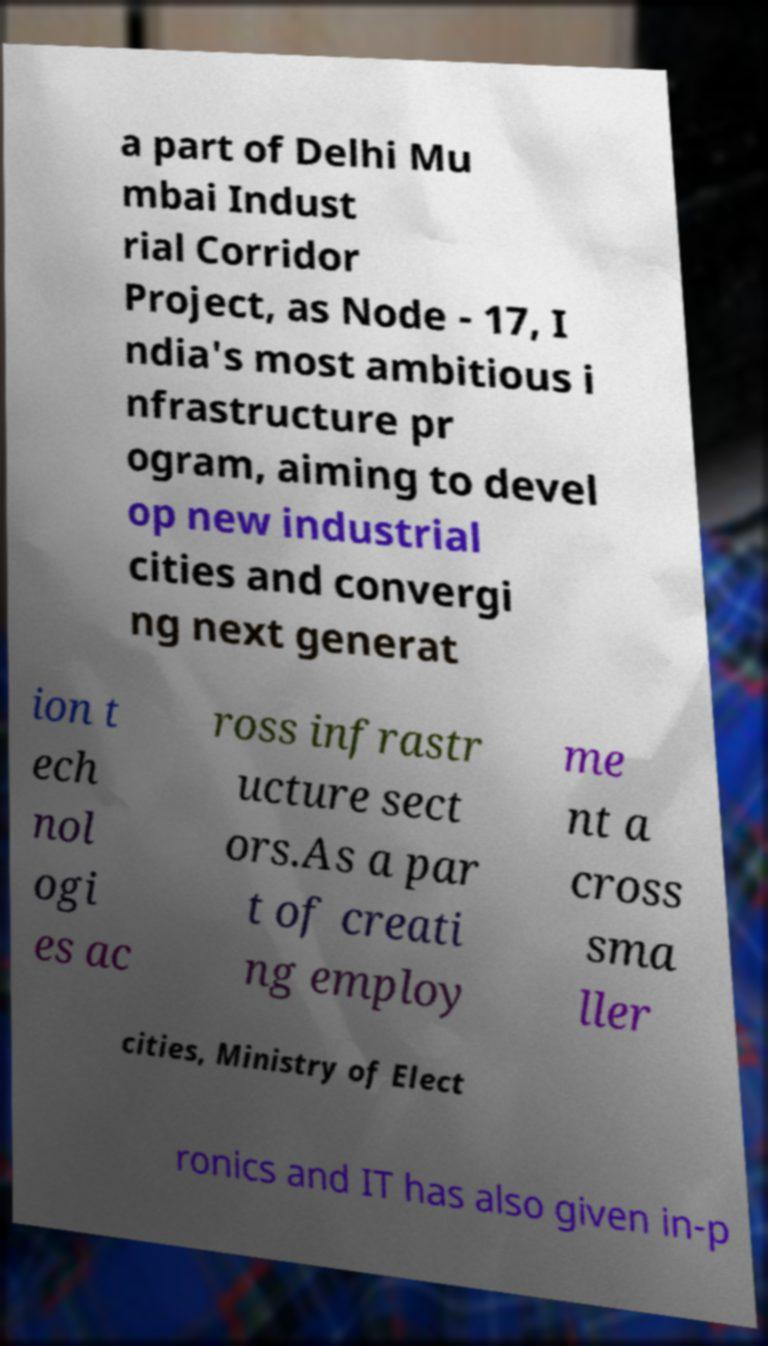Could you extract and type out the text from this image? a part of Delhi Mu mbai Indust rial Corridor Project, as Node - 17, I ndia's most ambitious i nfrastructure pr ogram, aiming to devel op new industrial cities and convergi ng next generat ion t ech nol ogi es ac ross infrastr ucture sect ors.As a par t of creati ng employ me nt a cross sma ller cities, Ministry of Elect ronics and IT has also given in-p 